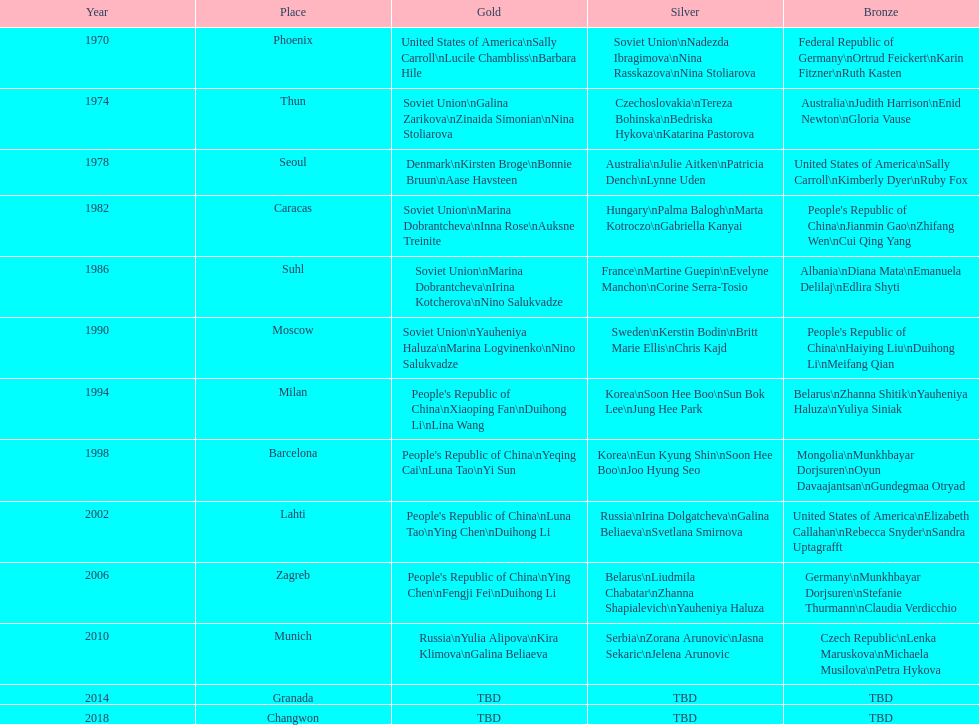How many world championships had the soviet union won first place in in the 25 metre pistol women's world championship? 4. Can you parse all the data within this table? {'header': ['Year', 'Place', 'Gold', 'Silver', 'Bronze'], 'rows': [['1970', 'Phoenix', 'United States of America\\nSally Carroll\\nLucile Chambliss\\nBarbara Hile', 'Soviet Union\\nNadezda Ibragimova\\nNina Rasskazova\\nNina Stoliarova', 'Federal Republic of Germany\\nOrtrud Feickert\\nKarin Fitzner\\nRuth Kasten'], ['1974', 'Thun', 'Soviet Union\\nGalina Zarikova\\nZinaida Simonian\\nNina Stoliarova', 'Czechoslovakia\\nTereza Bohinska\\nBedriska Hykova\\nKatarina Pastorova', 'Australia\\nJudith Harrison\\nEnid Newton\\nGloria Vause'], ['1978', 'Seoul', 'Denmark\\nKirsten Broge\\nBonnie Bruun\\nAase Havsteen', 'Australia\\nJulie Aitken\\nPatricia Dench\\nLynne Uden', 'United States of America\\nSally Carroll\\nKimberly Dyer\\nRuby Fox'], ['1982', 'Caracas', 'Soviet Union\\nMarina Dobrantcheva\\nInna Rose\\nAuksne Treinite', 'Hungary\\nPalma Balogh\\nMarta Kotroczo\\nGabriella Kanyai', "People's Republic of China\\nJianmin Gao\\nZhifang Wen\\nCui Qing Yang"], ['1986', 'Suhl', 'Soviet Union\\nMarina Dobrantcheva\\nIrina Kotcherova\\nNino Salukvadze', 'France\\nMartine Guepin\\nEvelyne Manchon\\nCorine Serra-Tosio', 'Albania\\nDiana Mata\\nEmanuela Delilaj\\nEdlira Shyti'], ['1990', 'Moscow', 'Soviet Union\\nYauheniya Haluza\\nMarina Logvinenko\\nNino Salukvadze', 'Sweden\\nKerstin Bodin\\nBritt Marie Ellis\\nChris Kajd', "People's Republic of China\\nHaiying Liu\\nDuihong Li\\nMeifang Qian"], ['1994', 'Milan', "People's Republic of China\\nXiaoping Fan\\nDuihong Li\\nLina Wang", 'Korea\\nSoon Hee Boo\\nSun Bok Lee\\nJung Hee Park', 'Belarus\\nZhanna Shitik\\nYauheniya Haluza\\nYuliya Siniak'], ['1998', 'Barcelona', "People's Republic of China\\nYeqing Cai\\nLuna Tao\\nYi Sun", 'Korea\\nEun Kyung Shin\\nSoon Hee Boo\\nJoo Hyung Seo', 'Mongolia\\nMunkhbayar Dorjsuren\\nOyun Davaajantsan\\nGundegmaa Otryad'], ['2002', 'Lahti', "People's Republic of China\\nLuna Tao\\nYing Chen\\nDuihong Li", 'Russia\\nIrina Dolgatcheva\\nGalina Beliaeva\\nSvetlana Smirnova', 'United States of America\\nElizabeth Callahan\\nRebecca Snyder\\nSandra Uptagrafft'], ['2006', 'Zagreb', "People's Republic of China\\nYing Chen\\nFengji Fei\\nDuihong Li", 'Belarus\\nLiudmila Chabatar\\nZhanna Shapialevich\\nYauheniya Haluza', 'Germany\\nMunkhbayar Dorjsuren\\nStefanie Thurmann\\nClaudia Verdicchio'], ['2010', 'Munich', 'Russia\\nYulia Alipova\\nKira Klimova\\nGalina Beliaeva', 'Serbia\\nZorana Arunovic\\nJasna Sekaric\\nJelena Arunovic', 'Czech Republic\\nLenka Maruskova\\nMichaela Musilova\\nPetra Hykova'], ['2014', 'Granada', 'TBD', 'TBD', 'TBD'], ['2018', 'Changwon', 'TBD', 'TBD', 'TBD']]} 